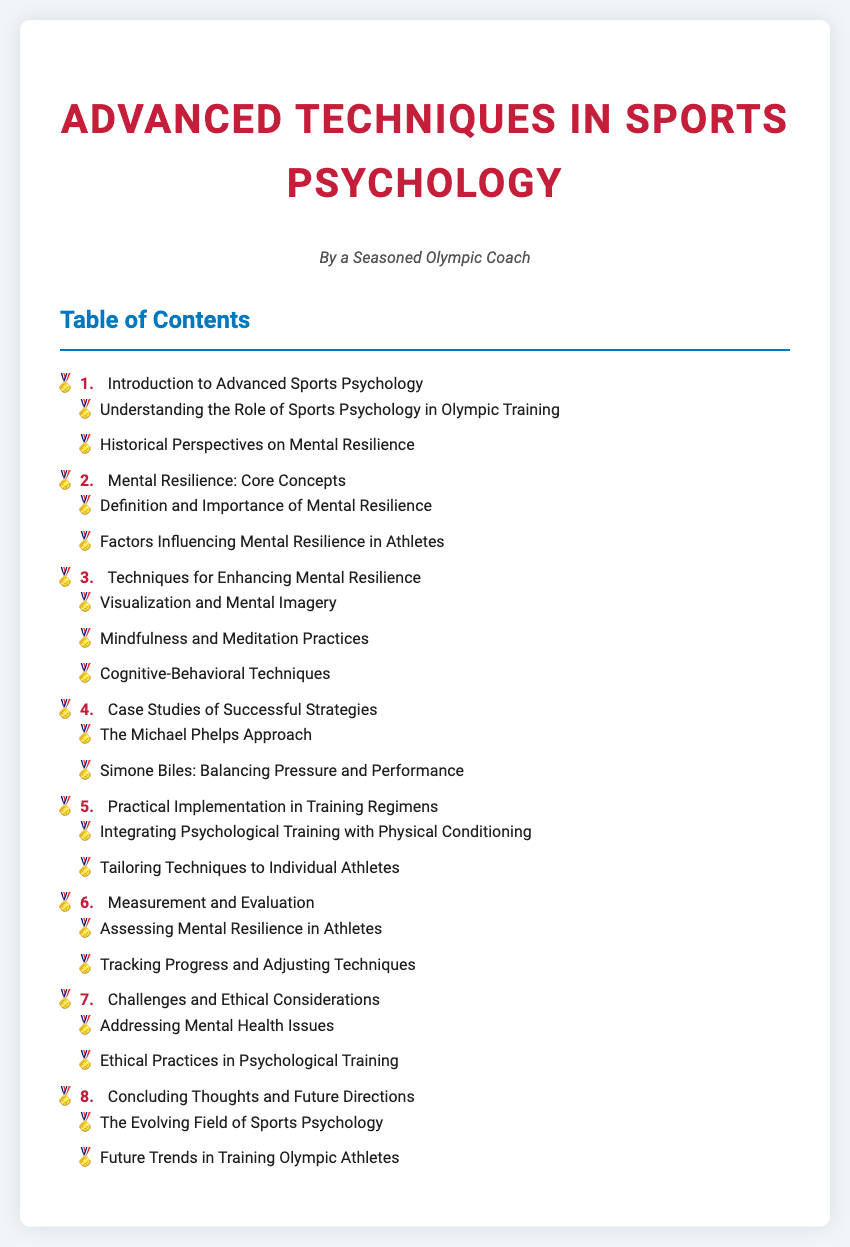What is the title of the document? The title is presented at the top of the document and is "Advanced Techniques in Sports Psychology: Enhancing Mental Resilience in Athletes."
Answer: Advanced Techniques in Sports Psychology: Enhancing Mental Resilience in Athletes Who is the author of the document? The author information is provided in the document and states "By a Seasoned Olympic Coach."
Answer: A Seasoned Olympic Coach What is the first topic in the table of contents? The first topic listed in the table of contents is "Introduction to Advanced Sports Psychology."
Answer: Introduction to Advanced Sports Psychology How many techniques are listed for enhancing mental resilience? There are three techniques listed under the section for enhancing mental resilience: Visualization and Mental Imagery, Mindfulness and Meditation Practices, and Cognitive-Behavioral Techniques.
Answer: Three What are the two case studies mentioned? The case studies mentioned in the document are "The Michael Phelps Approach" and "Simone Biles: Balancing Pressure and Performance."
Answer: The Michael Phelps Approach and Simone Biles: Balancing Pressure and Performance What is the last section in the table of contents? The last section in the table of contents is titled "Concluding Thoughts and Future Directions."
Answer: Concluding Thoughts and Future Directions What issue does the document address under challenges? The document addresses "Mental Health Issues" under the challenges section.
Answer: Mental Health Issues What does the document say about the future of training Olympic athletes? The document discusses "Future Trends in Training Olympic Athletes" as a part of its concluding thoughts.
Answer: Future Trends in Training Olympic Athletes 